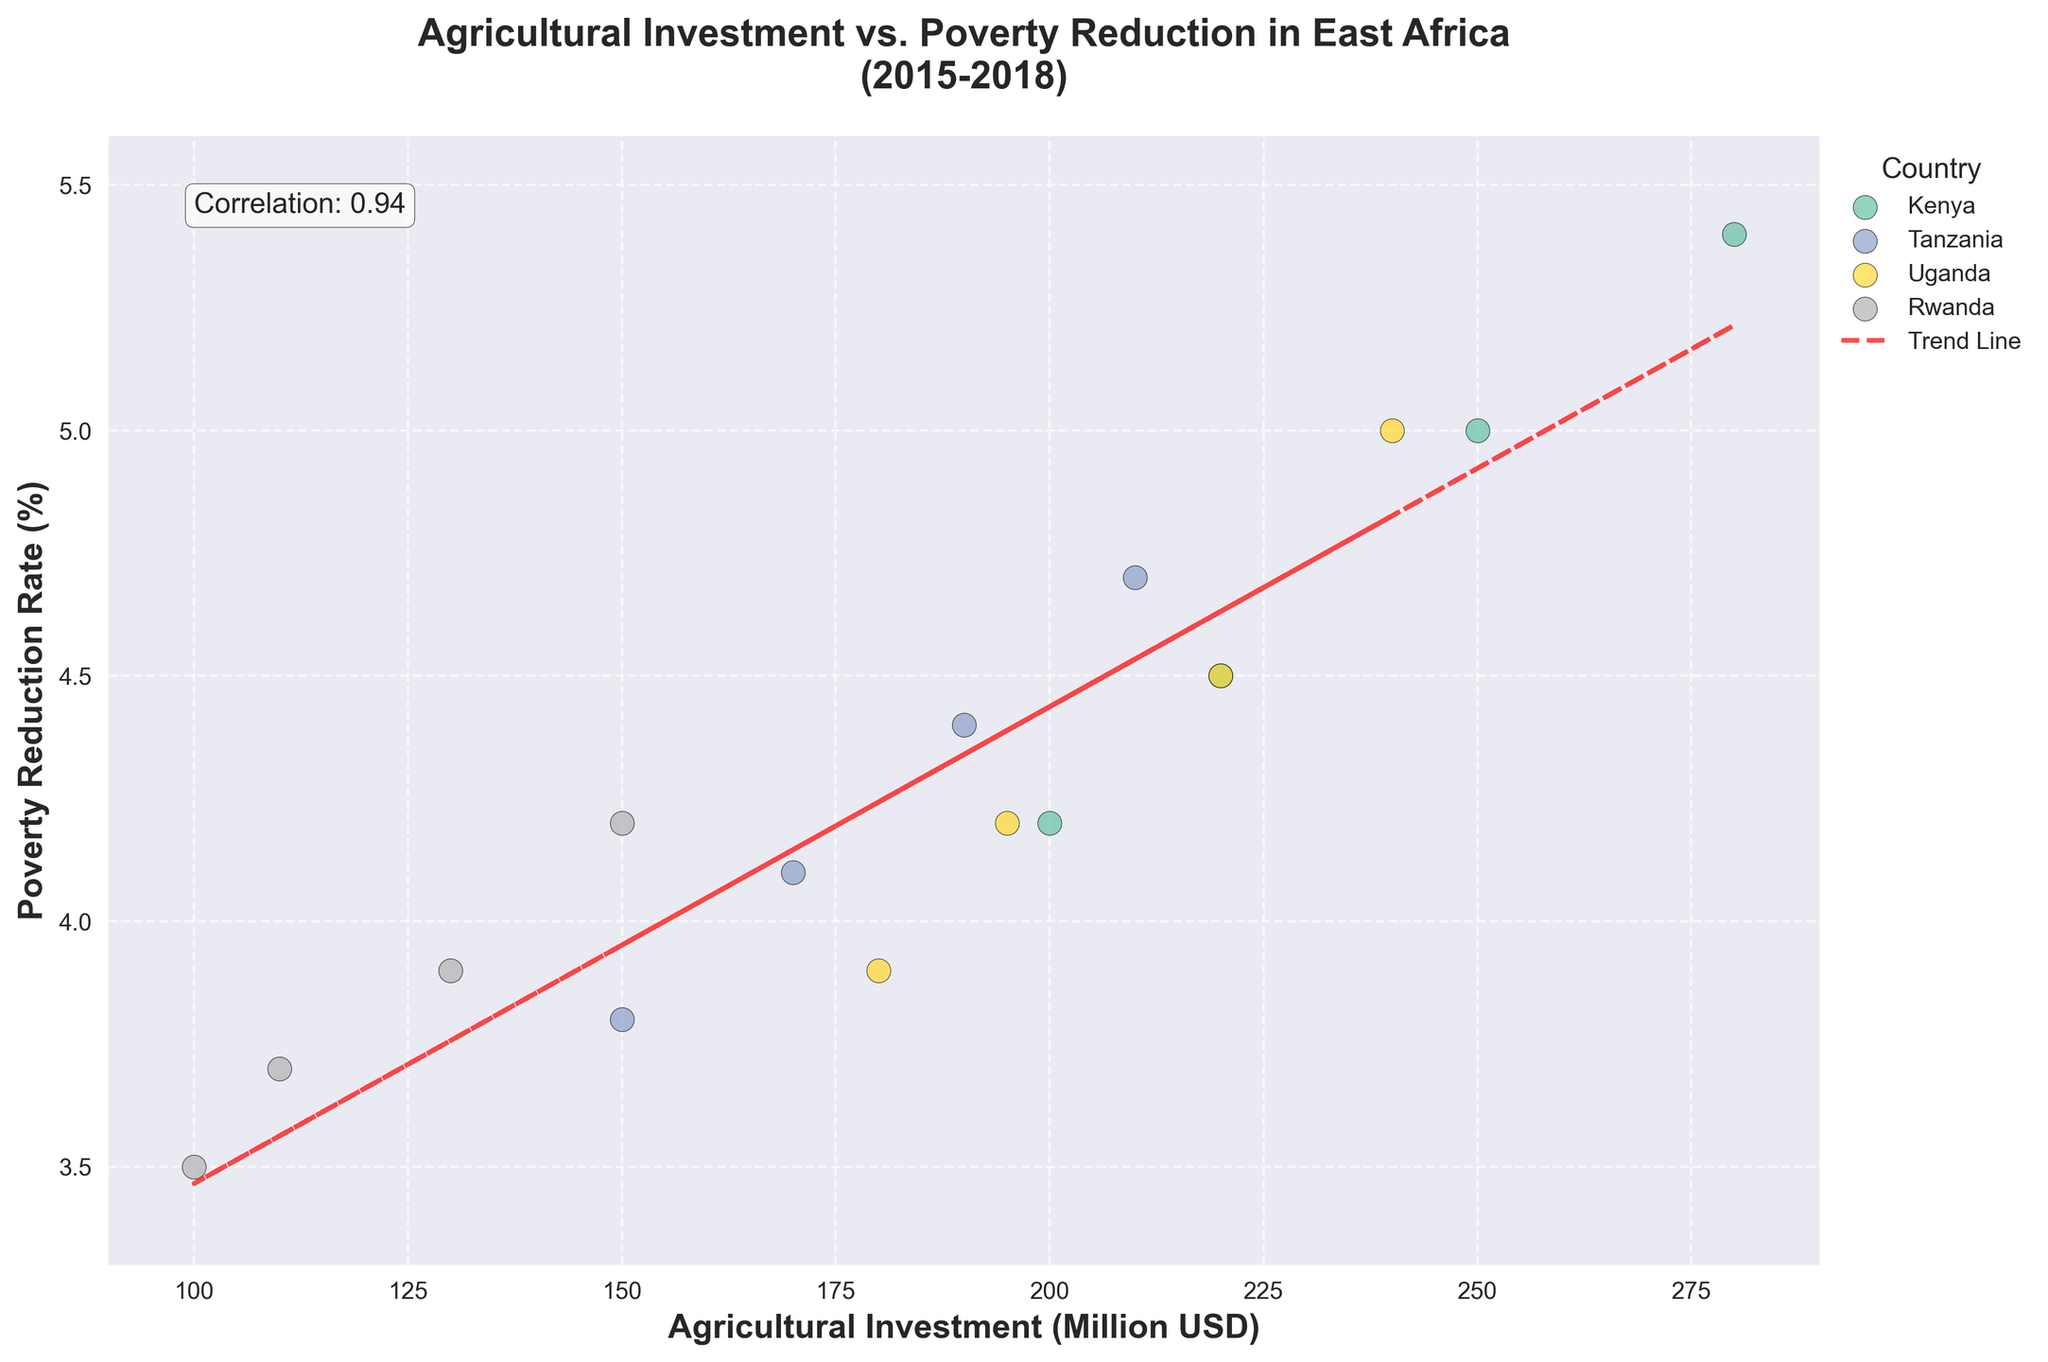What is the title of the figure? The title of the figure is prominently displayed at the top and reads "Agricultural Investment vs. Poverty Reduction in East Africa (2015-2018)". This is usually the first element you see when looking at a graph.
Answer: Agricultural Investment vs. Poverty Reduction in East Africa (2015-2018) Which country has the highest agricultural investment and what is its corresponding poverty reduction rate? To find the country with the highest agricultural investment, look for the data point furthest to the right. This data point represents Kenya in 2018, with a $280 million investment and a poverty reduction rate of 5.4%.
Answer: Kenya, 5.4% What is the range of agricultural investment in the data set? The range of agricultural investment is found by identifying the minimum and maximum values along the x-axis. The minimum value is $100 million (Rwanda in 2015) and the maximum value is $280 million (Kenya in 2018). The range is $280 million - $100 million = $180 million.
Answer: 180 million USD Among the countries, which one has the lowest observed poverty reduction rate, and what is the corresponding agricultural investment? To answer this, find the lowest data point along the y-axis. This represents Rwanda in 2015, with a poverty reduction rate of 3.5% and an agricultural investment of $100 million.
Answer: Rwanda, 100 million USD What is the correlation coefficient between agricultural investment and poverty reduction rate? The correlation coefficient is displayed as a text annotation within the figure. It indicates a value of 0.85. This coefficient is a statistical measure that indicates the strength and direction of a linear relationship between the two variables.
Answer: 0.85 How does the trend line aid in understanding the relationship between agricultural investment and poverty reduction? The trend line shows the general direction of the relationship between the two variables. It is positively sloped, indicating that as agricultural investment increases, the poverty reduction rate also tends to increase, suggesting a positive linear relationship.
Answer: Positive linear relationship Compare Kenya and Tanzania's agricultural investment and poverty reduction rates in 2018. Which country had greater values in both metrics? In 2018, Kenya had an agricultural investment of $280 million and a poverty reduction rate of 5.4%. Tanzania had an agricultural investment of $210 million and a poverty reduction rate of 4.7%. Kenya had greater values in both agricultural investment and poverty reduction rate.
Answer: Kenya What is the overall trend of agricultural investment from 2015 to 2018 for each country? The trend can be observed by noting the movement of data points from 2015 to 2018 for each country. Kenya, Tanzania, Uganda, and Rwanda all show an upward trend in agricultural investment over these years, indicating increasing investments.
Answer: Upward trend for all countries What can you infer about the likely impact of agricultural investment on poverty reduction based on this scatter plot? Based on the scatter plot and the positively sloped trend line, we can infer that higher agricultural investments are generally associated with higher rates of poverty reduction in the rural areas of East Africa from 2015 to 2018.
Answer: Higher investment likely leads to higher poverty reduction Which country had the smallest increase in agricultural investment between 2015 and 2018, and by how much did it increase? To determine this, look at the change in agricultural investment for each country from 2015 to 2018. Rwanda had the smallest increase, starting at $100 million in 2015 and growing to $150 million in 2018. The increase is $150 million - $100 million = $50 million.
Answer: Rwanda, 50 million USD 